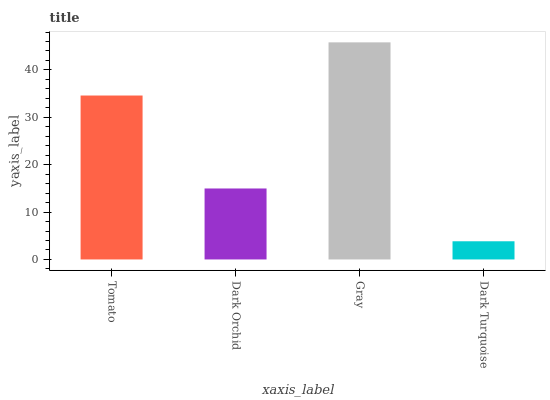Is Dark Turquoise the minimum?
Answer yes or no. Yes. Is Gray the maximum?
Answer yes or no. Yes. Is Dark Orchid the minimum?
Answer yes or no. No. Is Dark Orchid the maximum?
Answer yes or no. No. Is Tomato greater than Dark Orchid?
Answer yes or no. Yes. Is Dark Orchid less than Tomato?
Answer yes or no. Yes. Is Dark Orchid greater than Tomato?
Answer yes or no. No. Is Tomato less than Dark Orchid?
Answer yes or no. No. Is Tomato the high median?
Answer yes or no. Yes. Is Dark Orchid the low median?
Answer yes or no. Yes. Is Dark Orchid the high median?
Answer yes or no. No. Is Gray the low median?
Answer yes or no. No. 